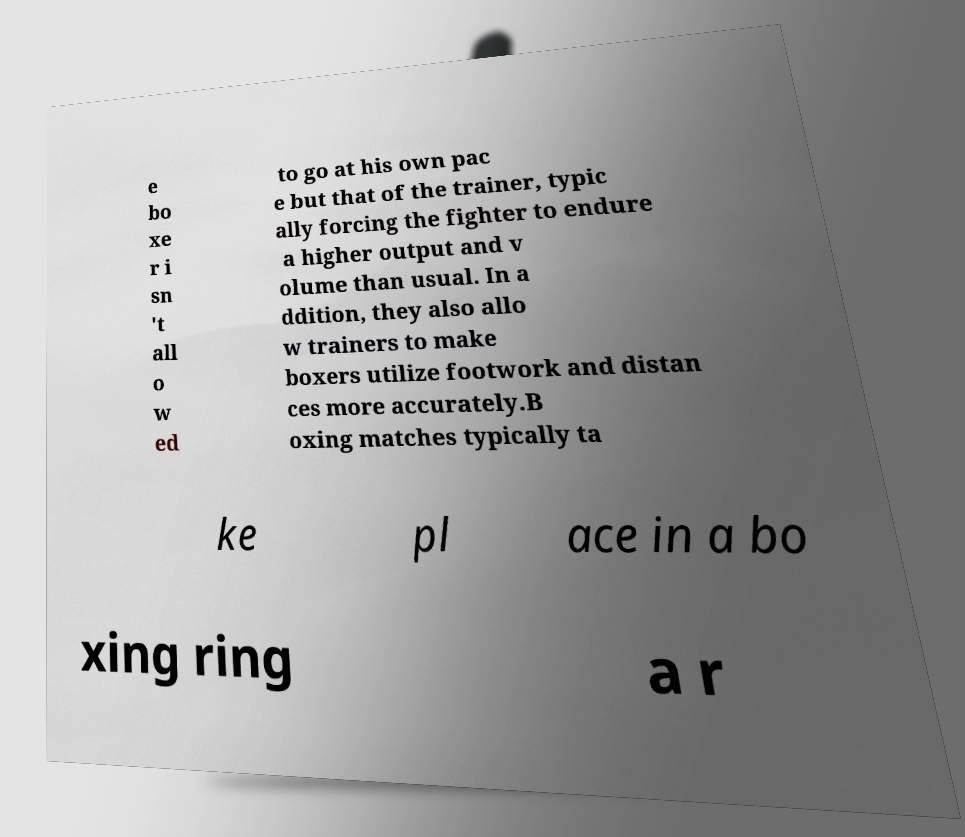Please read and relay the text visible in this image. What does it say? e bo xe r i sn 't all o w ed to go at his own pac e but that of the trainer, typic ally forcing the fighter to endure a higher output and v olume than usual. In a ddition, they also allo w trainers to make boxers utilize footwork and distan ces more accurately.B oxing matches typically ta ke pl ace in a bo xing ring a r 